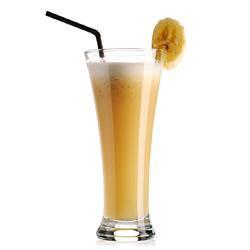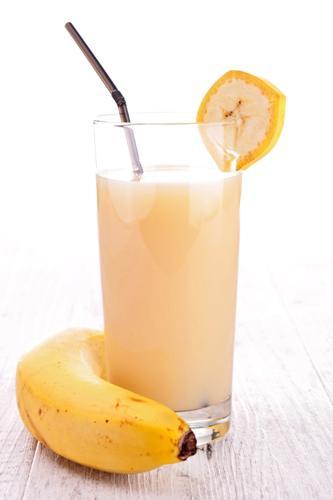The first image is the image on the left, the second image is the image on the right. Analyze the images presented: Is the assertion "All the bananas are cut." valid? Answer yes or no. No. 